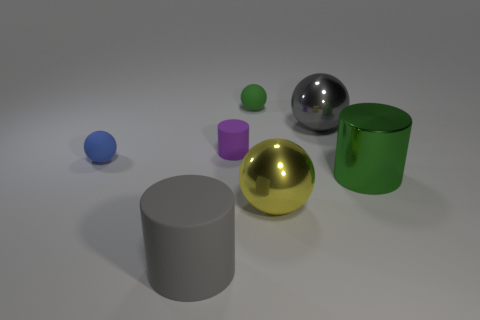Is the large green thing made of the same material as the purple object?
Offer a very short reply. No. Are there more big matte objects in front of the small purple rubber cylinder than small metal blocks?
Offer a very short reply. Yes. How many objects are large yellow metal spheres or spheres in front of the small green matte thing?
Provide a short and direct response. 3. Is the number of matte cylinders behind the large green shiny object greater than the number of tiny blue matte spheres right of the small blue matte thing?
Your answer should be very brief. Yes. What is the material of the ball left of the small ball that is behind the big sphere that is behind the blue rubber thing?
Offer a very short reply. Rubber. What shape is the tiny green thing that is made of the same material as the big gray cylinder?
Provide a short and direct response. Sphere. There is a metal ball that is in front of the small blue rubber sphere; are there any yellow spheres left of it?
Your answer should be very brief. No. What is the size of the blue rubber thing?
Your response must be concise. Small. How many things are either small yellow cubes or small green matte things?
Provide a succinct answer. 1. Is the material of the ball on the left side of the small purple matte cylinder the same as the gray object to the right of the gray rubber object?
Keep it short and to the point. No. 